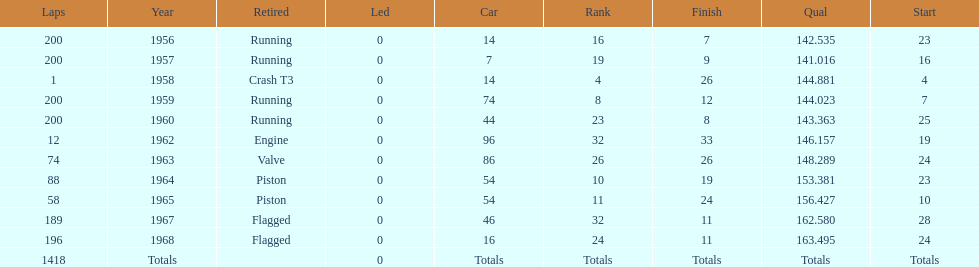How many times did he finish all 200 laps? 4. 